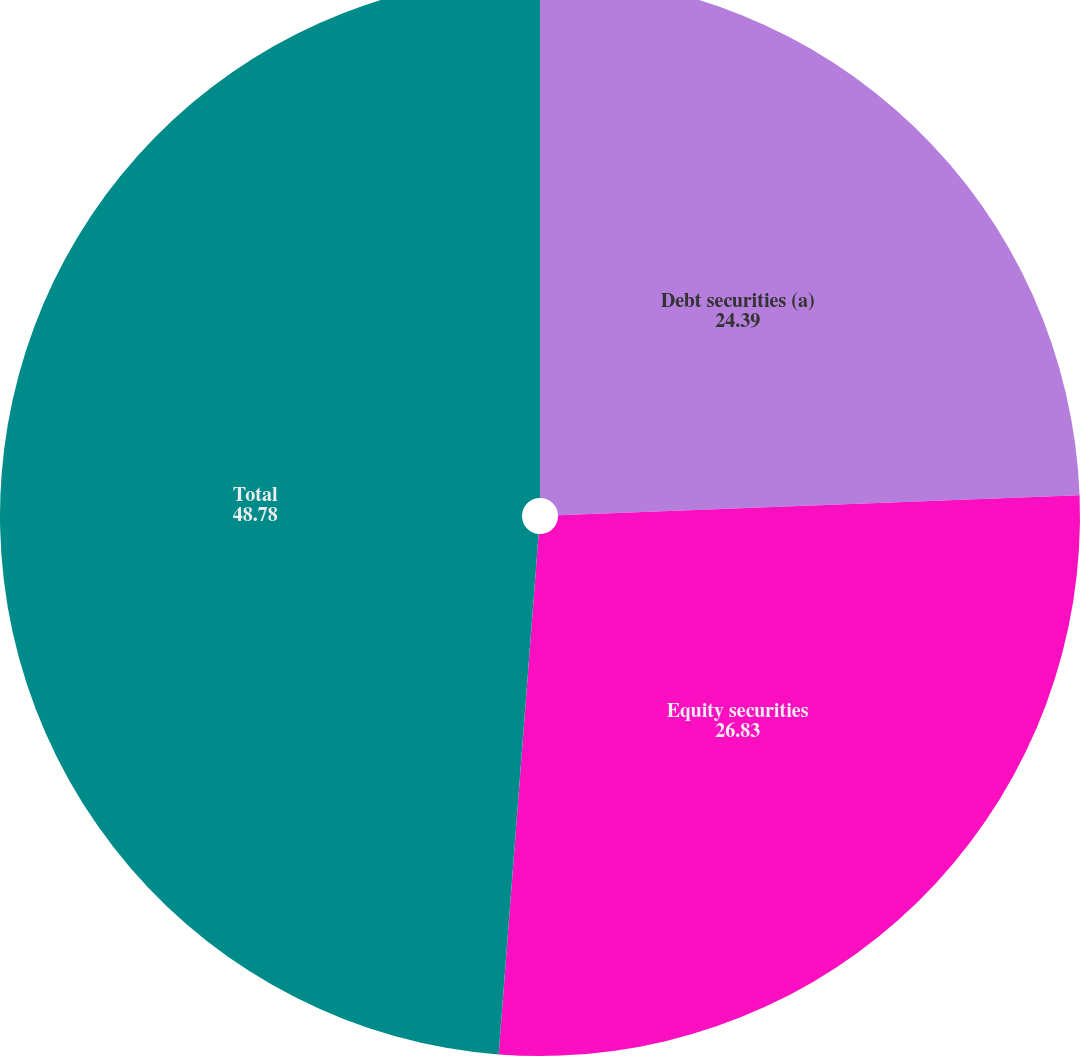Convert chart to OTSL. <chart><loc_0><loc_0><loc_500><loc_500><pie_chart><fcel>Debt securities (a)<fcel>Equity securities<fcel>Total<nl><fcel>24.39%<fcel>26.83%<fcel>48.78%<nl></chart> 